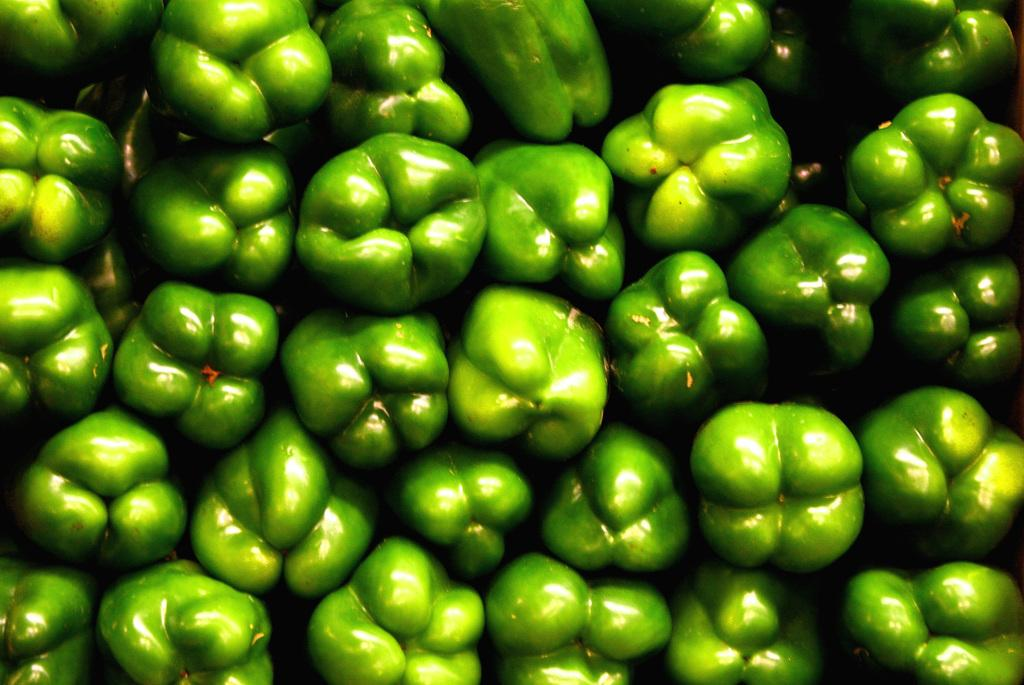What type of food can be seen in the image? There are vegetables in the image. How many dinosaurs are present in the image? There are no dinosaurs present in the image; it features vegetables. What level of experience does the maid have in the image? There is no maid present in the image, so it is not possible to determine their level of experience. 